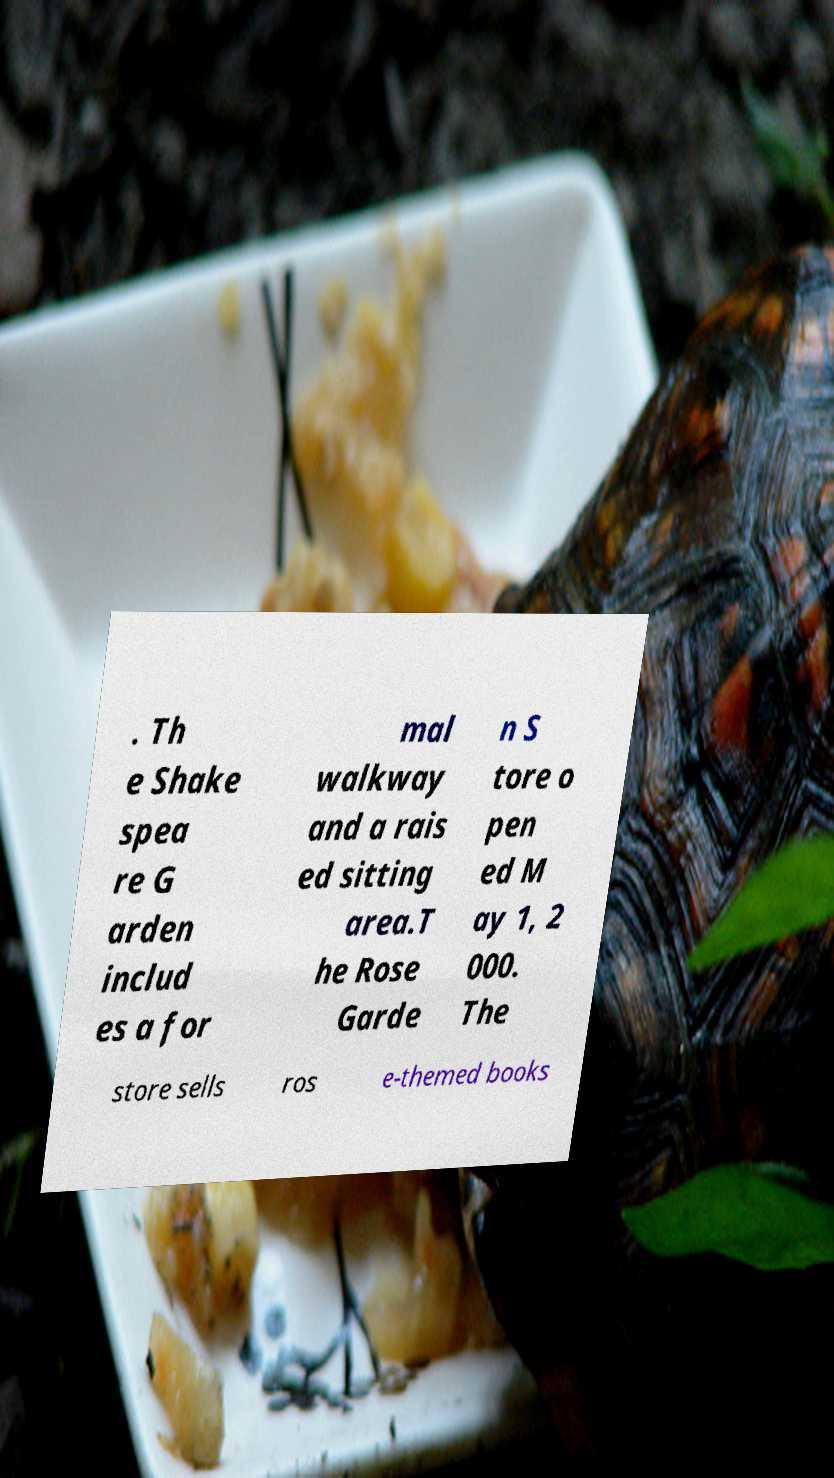Could you extract and type out the text from this image? . Th e Shake spea re G arden includ es a for mal walkway and a rais ed sitting area.T he Rose Garde n S tore o pen ed M ay 1, 2 000. The store sells ros e-themed books 